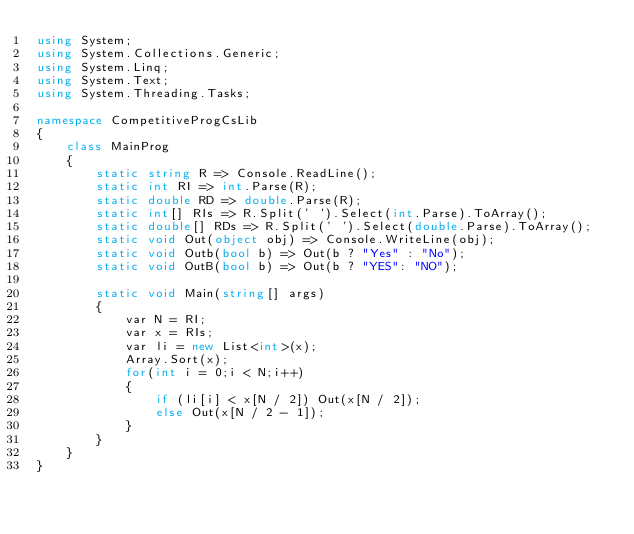Convert code to text. <code><loc_0><loc_0><loc_500><loc_500><_C#_>using System;
using System.Collections.Generic;
using System.Linq;
using System.Text;
using System.Threading.Tasks;

namespace CompetitiveProgCsLib
{
	class MainProg
	{
		static string R => Console.ReadLine();
		static int RI => int.Parse(R);
		static double RD => double.Parse(R);
		static int[] RIs => R.Split(' ').Select(int.Parse).ToArray();
		static double[] RDs => R.Split(' ').Select(double.Parse).ToArray();
		static void Out(object obj) => Console.WriteLine(obj);
		static void Outb(bool b) => Out(b ? "Yes" : "No");
		static void OutB(bool b) => Out(b ? "YES": "NO");

		static void Main(string[] args)
		{
			var N = RI;
			var x = RIs;
			var li = new List<int>(x);
			Array.Sort(x);
			for(int i = 0;i < N;i++)
			{
				if (li[i] < x[N / 2]) Out(x[N / 2]);
				else Out(x[N / 2 - 1]);
			}
		}
	}
}
</code> 